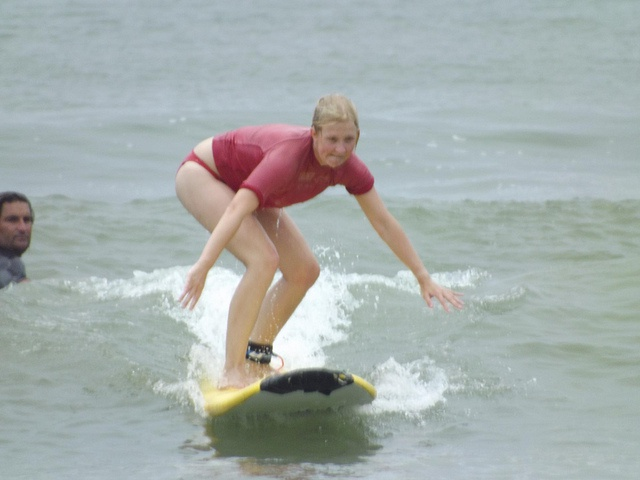Describe the objects in this image and their specific colors. I can see people in darkgray, tan, and brown tones, surfboard in darkgray, gray, black, khaki, and olive tones, and people in darkgray, gray, and black tones in this image. 